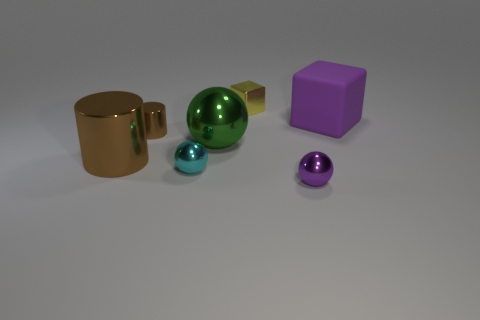Is there any other thing that has the same material as the large purple object?
Provide a succinct answer. No. There is a ball behind the tiny sphere on the left side of the shiny ball that is on the right side of the large green sphere; what size is it?
Your response must be concise. Large. There is a yellow metallic thing; are there any metallic things in front of it?
Your answer should be compact. Yes. What size is the cyan thing that is made of the same material as the green ball?
Your answer should be very brief. Small. How many yellow shiny objects are the same shape as the large matte object?
Provide a succinct answer. 1. Do the large cylinder and the thing that is behind the purple matte thing have the same material?
Your response must be concise. Yes. Is the number of large cylinders on the left side of the small cyan object greater than the number of tiny brown rubber things?
Give a very brief answer. Yes. The tiny shiny thing that is the same color as the large metallic cylinder is what shape?
Your response must be concise. Cylinder. Are there any big brown spheres made of the same material as the big green object?
Provide a short and direct response. No. Do the green object that is to the right of the tiny cyan sphere and the block that is to the right of the tiny yellow block have the same material?
Your answer should be compact. No. 